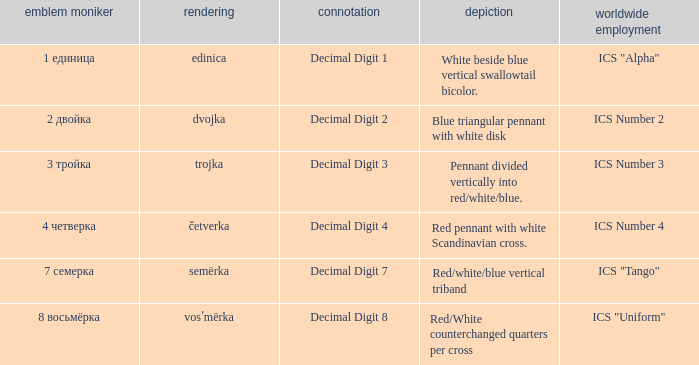What are the meanings of the flag whose name transliterates to semërka? Decimal Digit 7. 